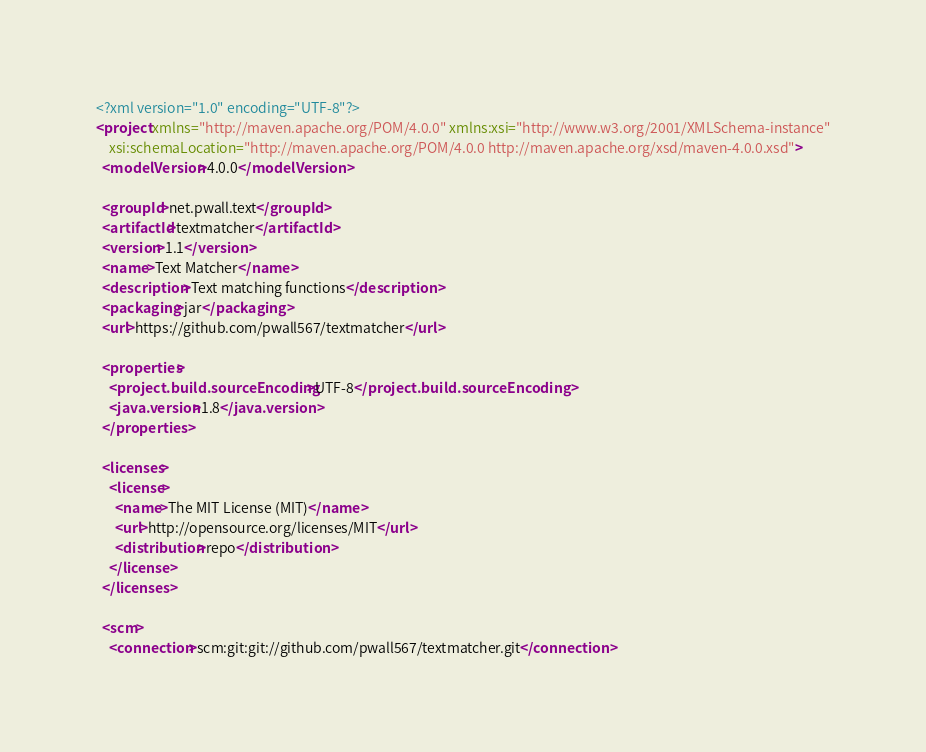<code> <loc_0><loc_0><loc_500><loc_500><_XML_><?xml version="1.0" encoding="UTF-8"?>
<project xmlns="http://maven.apache.org/POM/4.0.0" xmlns:xsi="http://www.w3.org/2001/XMLSchema-instance"
    xsi:schemaLocation="http://maven.apache.org/POM/4.0.0 http://maven.apache.org/xsd/maven-4.0.0.xsd">
  <modelVersion>4.0.0</modelVersion>

  <groupId>net.pwall.text</groupId>
  <artifactId>textmatcher</artifactId>
  <version>1.1</version>
  <name>Text Matcher</name>
  <description>Text matching functions</description>
  <packaging>jar</packaging>
  <url>https://github.com/pwall567/textmatcher</url>

  <properties>
    <project.build.sourceEncoding>UTF-8</project.build.sourceEncoding>
    <java.version>1.8</java.version>
  </properties>

  <licenses>
    <license>
      <name>The MIT License (MIT)</name>
      <url>http://opensource.org/licenses/MIT</url>
      <distribution>repo</distribution>
    </license>
  </licenses>

  <scm>
    <connection>scm:git:git://github.com/pwall567/textmatcher.git</connection></code> 